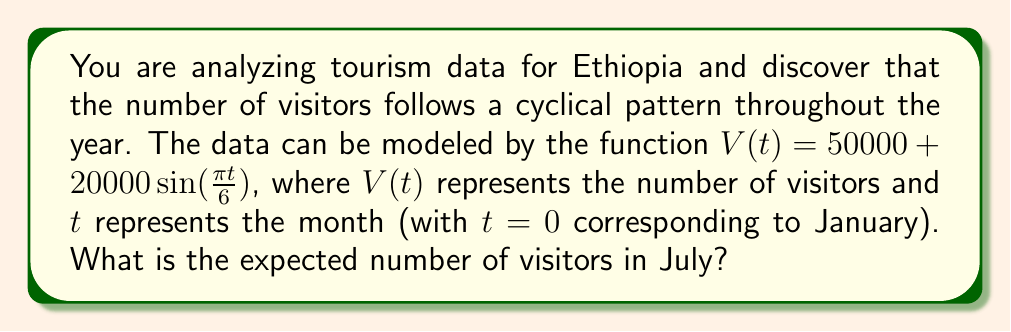Give your solution to this math problem. Let's approach this step-by-step:

1) First, we need to identify which month July corresponds to in our model. Since January is $t=0$, July would be $t=6$.

2) Now, we can substitute $t=6$ into our function:

   $V(6) = 50000 + 20000\sin(\frac{\pi \cdot 6}{6})$

3) Simplify the argument of the sine function:

   $V(6) = 50000 + 20000\sin(\pi)$

4) Recall that $\sin(\pi) = 0$:

   $V(6) = 50000 + 20000 \cdot 0$

5) Simplify:

   $V(6) = 50000 + 0 = 50000$

Therefore, the expected number of visitors in July is 50,000.
Answer: 50,000 visitors 